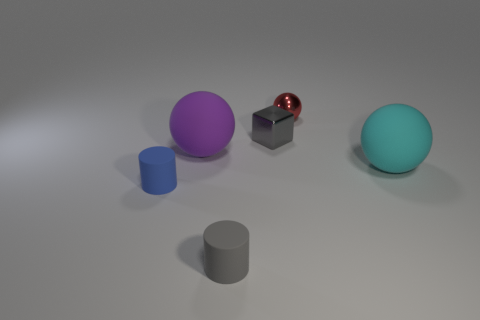There is a gray object in front of the large matte ball on the left side of the tiny matte cylinder that is right of the tiny blue matte thing; what size is it?
Provide a short and direct response. Small. There is a matte thing that is the same size as the blue cylinder; what shape is it?
Offer a terse response. Cylinder. What number of things are either big spheres behind the cyan rubber thing or large red matte objects?
Offer a terse response. 1. There is a rubber object behind the large thing that is to the right of the red metallic sphere; are there any small gray rubber cylinders right of it?
Provide a short and direct response. Yes. How many small metallic objects are there?
Your answer should be very brief. 2. How many objects are big matte balls that are to the left of the red shiny thing or purple matte objects left of the cyan rubber thing?
Your answer should be compact. 1. There is a blue matte cylinder in front of the cyan sphere; is its size the same as the red ball?
Provide a short and direct response. Yes. What is the size of the blue thing that is the same shape as the gray matte thing?
Keep it short and to the point. Small. There is a blue cylinder that is the same size as the metallic block; what is it made of?
Keep it short and to the point. Rubber. There is another small object that is the same shape as the purple object; what material is it?
Offer a terse response. Metal. 